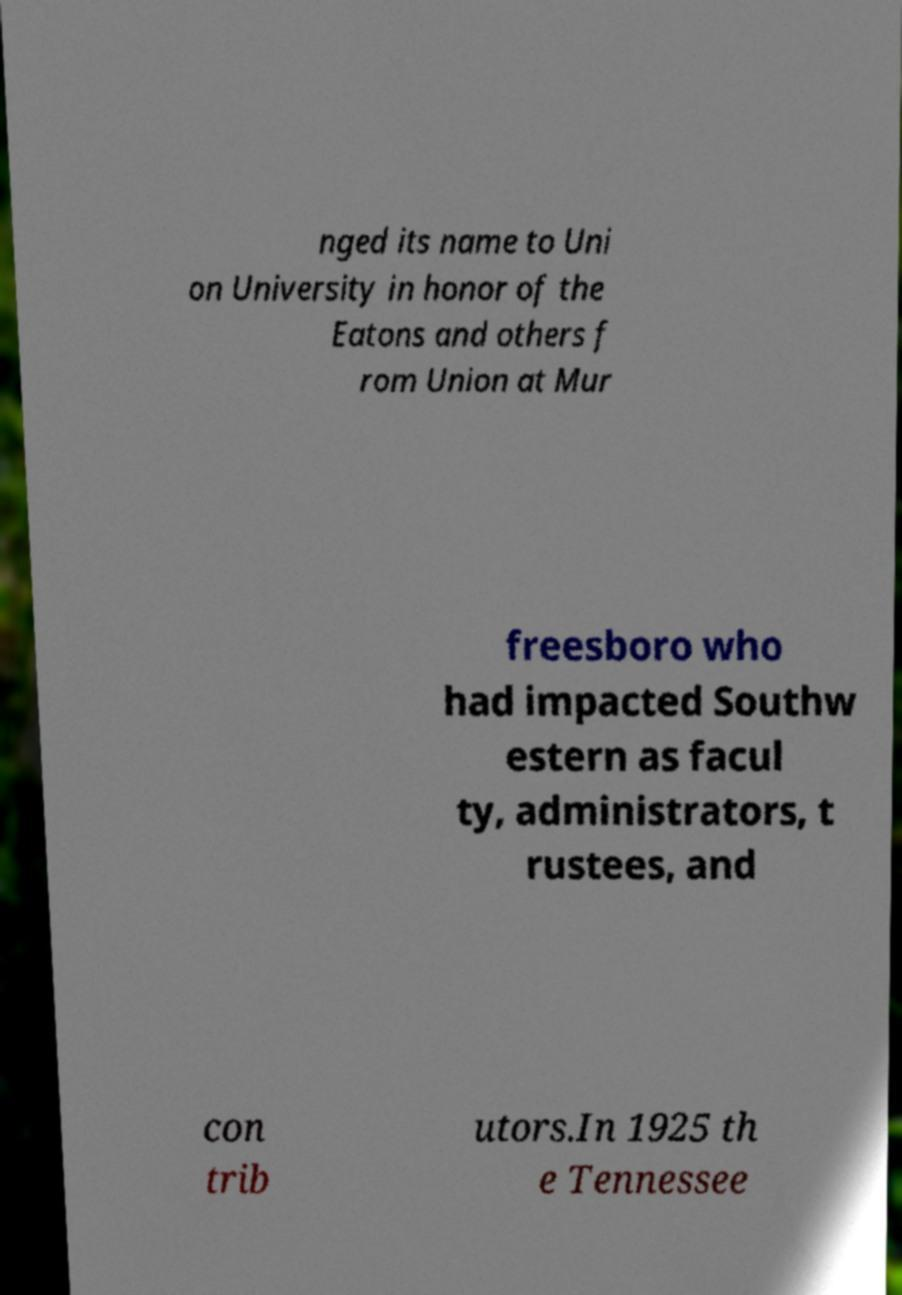Please identify and transcribe the text found in this image. nged its name to Uni on University in honor of the Eatons and others f rom Union at Mur freesboro who had impacted Southw estern as facul ty, administrators, t rustees, and con trib utors.In 1925 th e Tennessee 